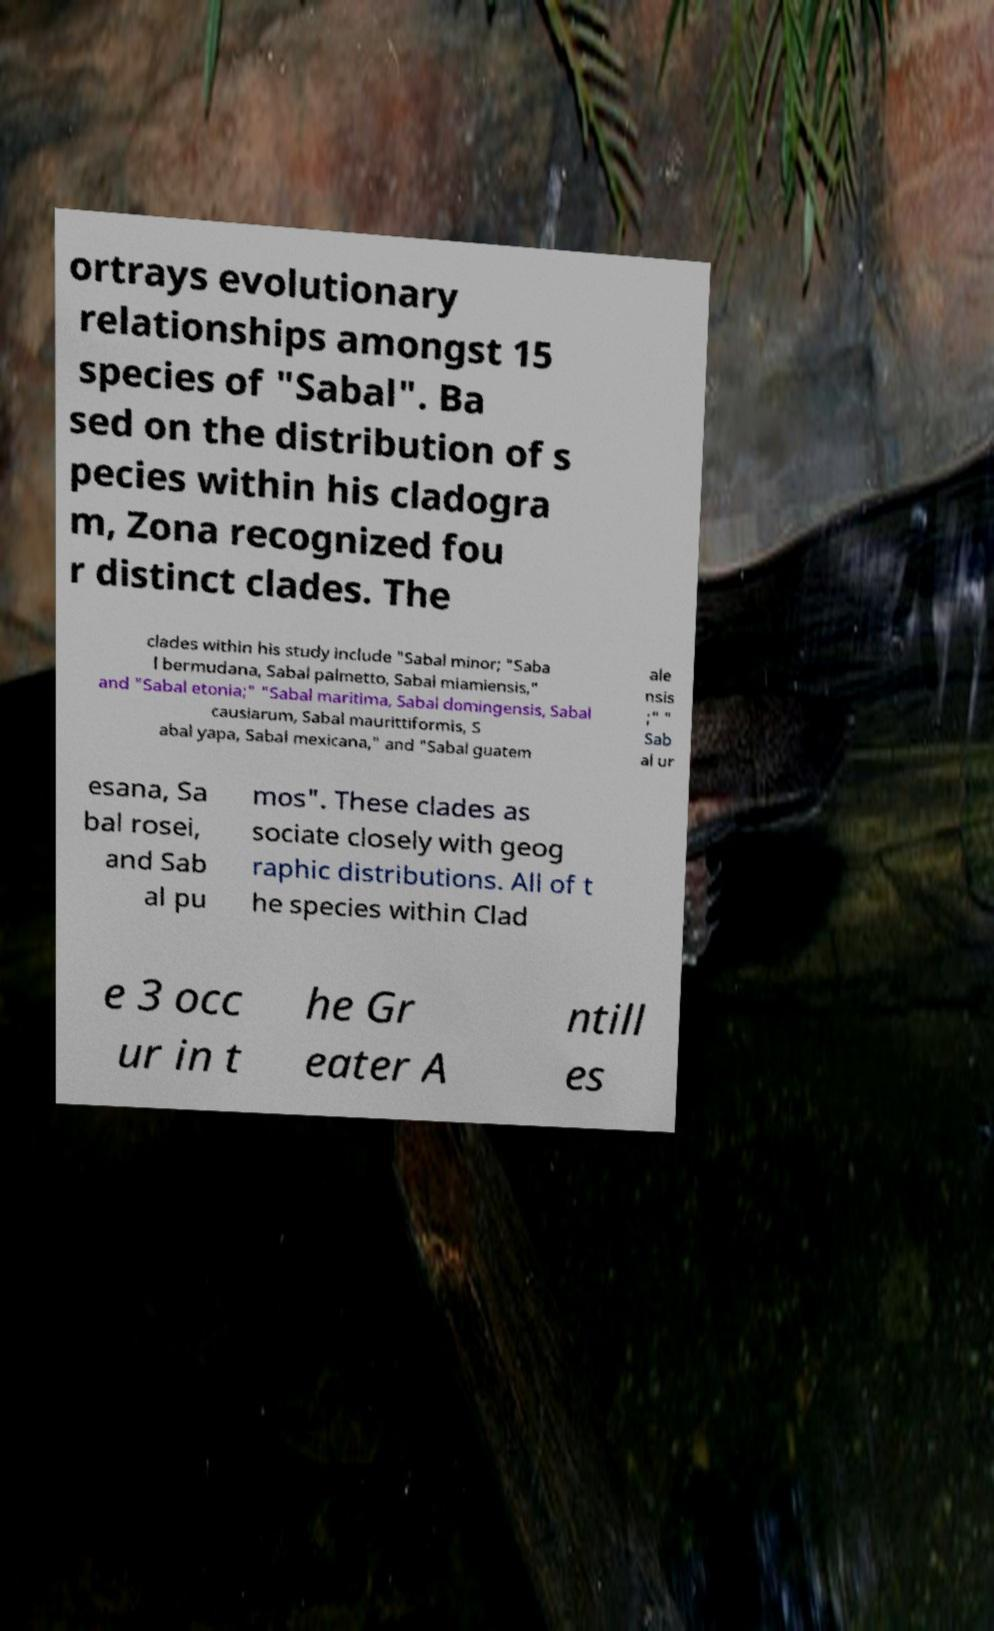I need the written content from this picture converted into text. Can you do that? ortrays evolutionary relationships amongst 15 species of "Sabal". Ba sed on the distribution of s pecies within his cladogra m, Zona recognized fou r distinct clades. The clades within his study include "Sabal minor; "Saba l bermudana, Sabal palmetto, Sabal miamiensis," and "Sabal etonia;" "Sabal maritima, Sabal domingensis, Sabal causiarum, Sabal maurittiformis, S abal yapa, Sabal mexicana," and "Sabal guatem ale nsis ;" " Sab al ur esana, Sa bal rosei, and Sab al pu mos". These clades as sociate closely with geog raphic distributions. All of t he species within Clad e 3 occ ur in t he Gr eater A ntill es 